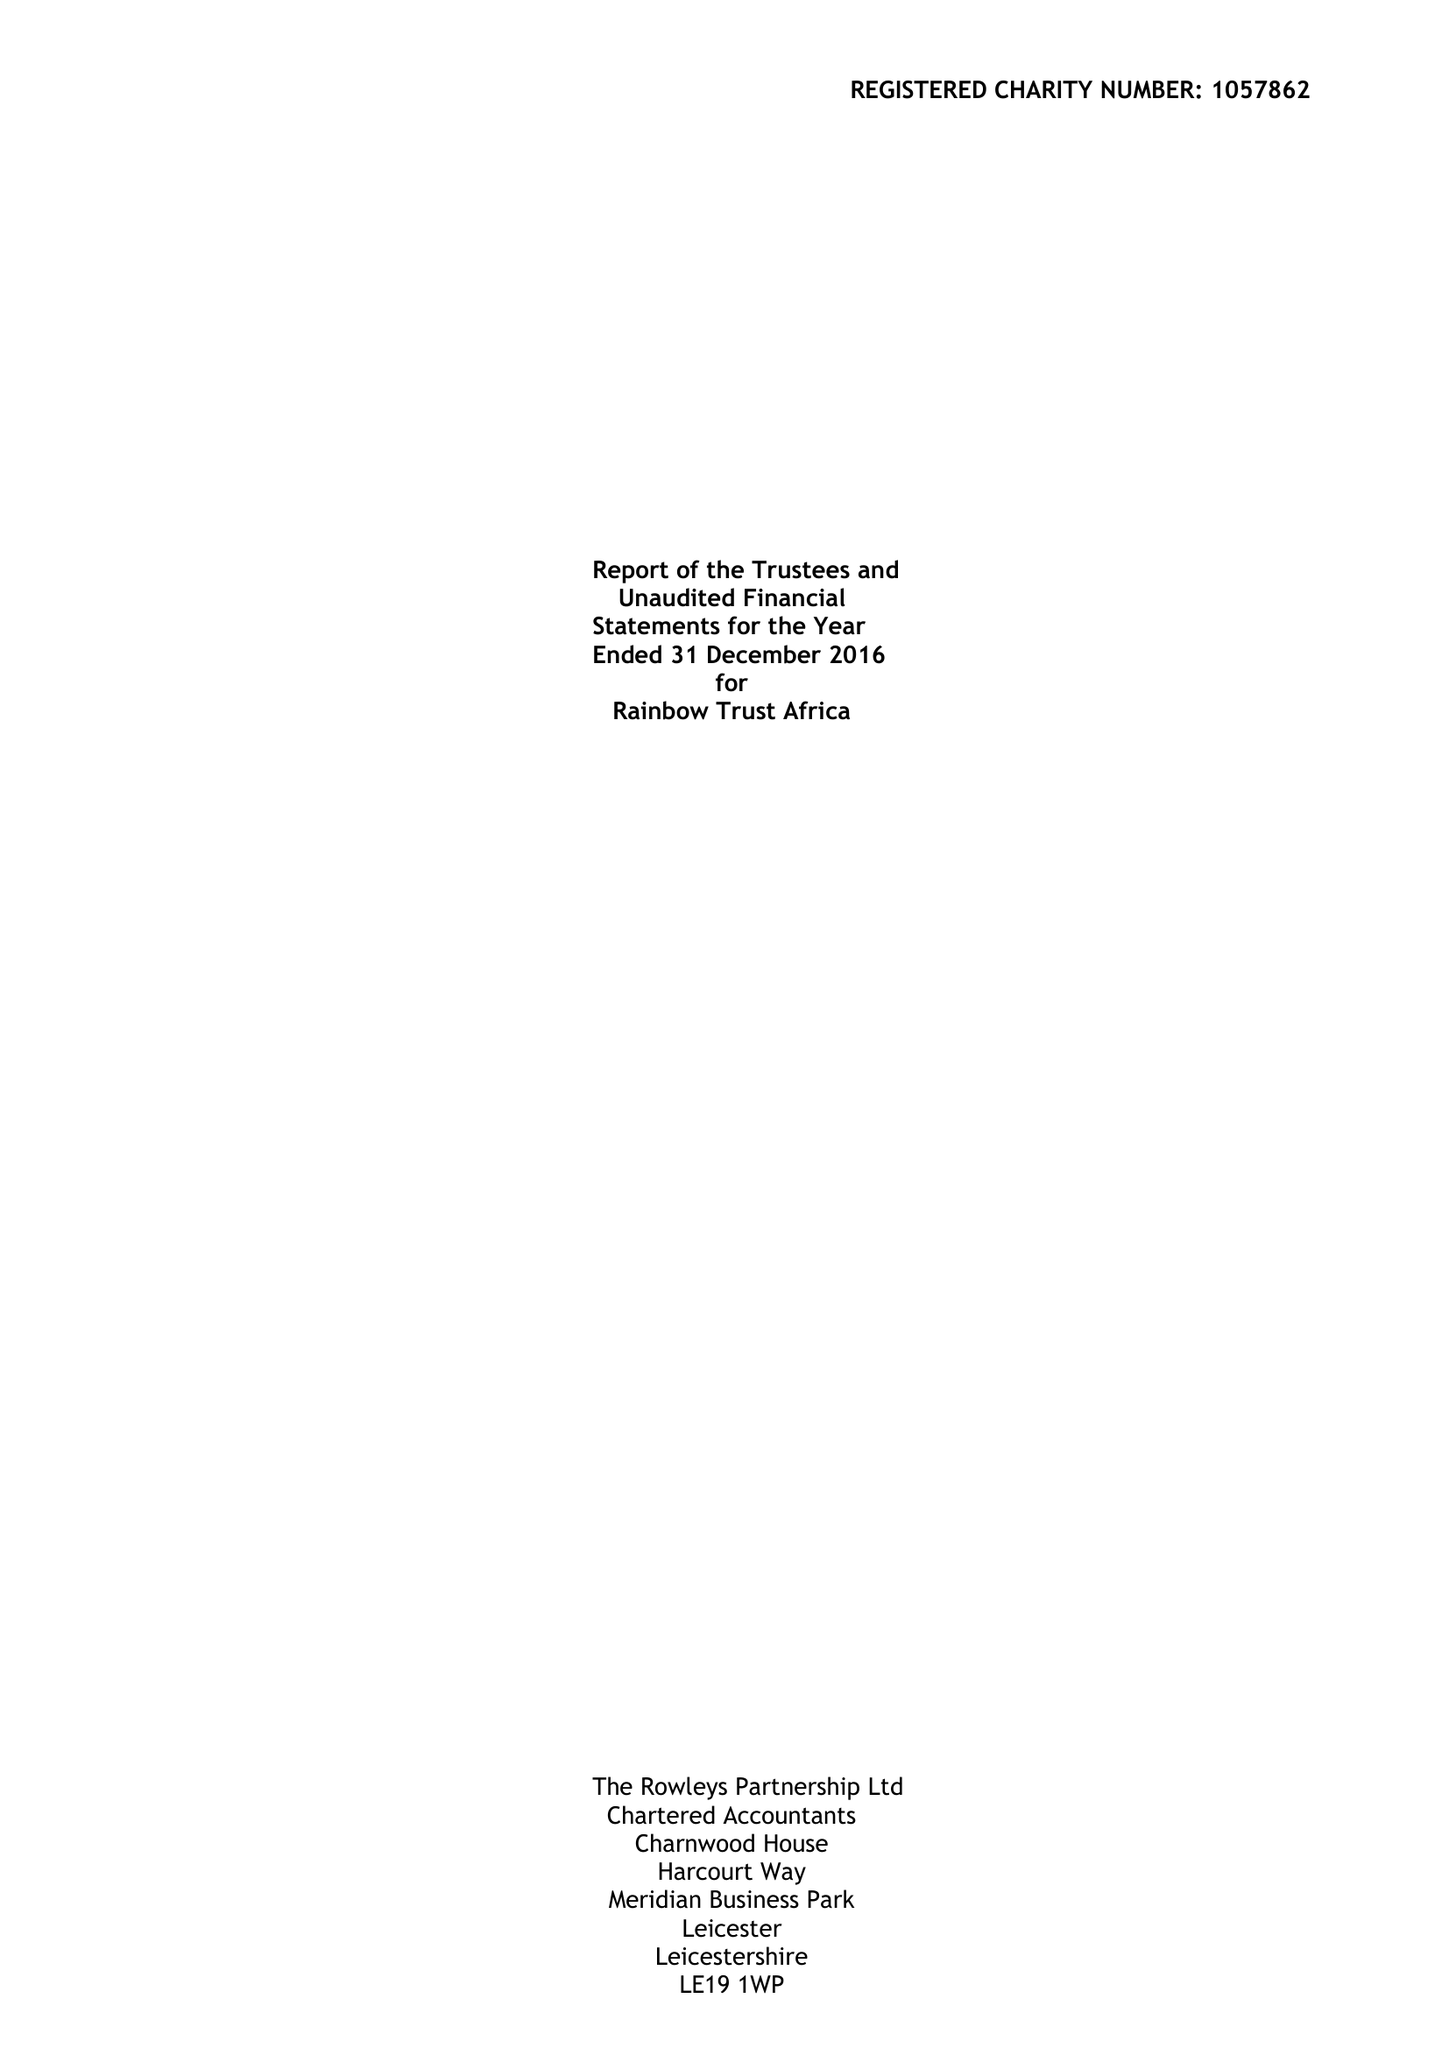What is the value for the charity_number?
Answer the question using a single word or phrase. 1057862 